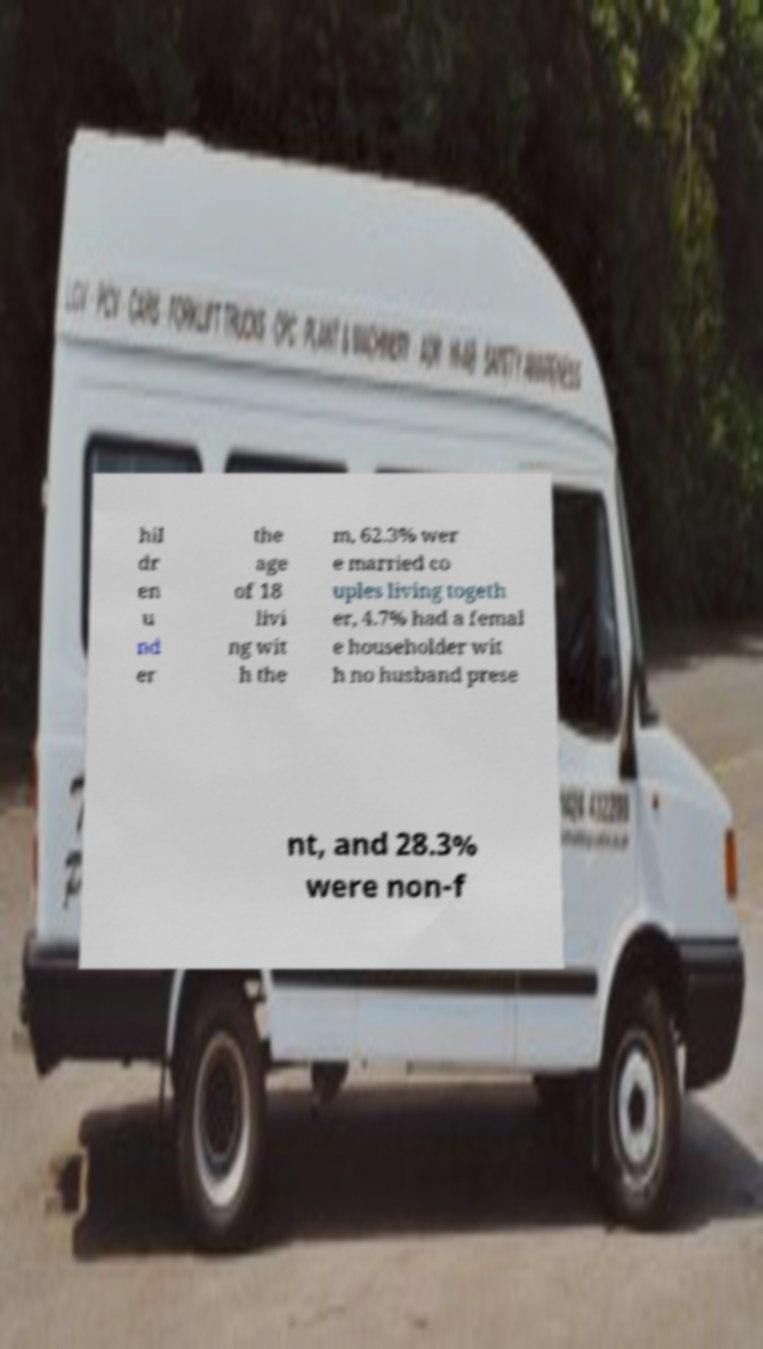Please identify and transcribe the text found in this image. hil dr en u nd er the age of 18 livi ng wit h the m, 62.3% wer e married co uples living togeth er, 4.7% had a femal e householder wit h no husband prese nt, and 28.3% were non-f 